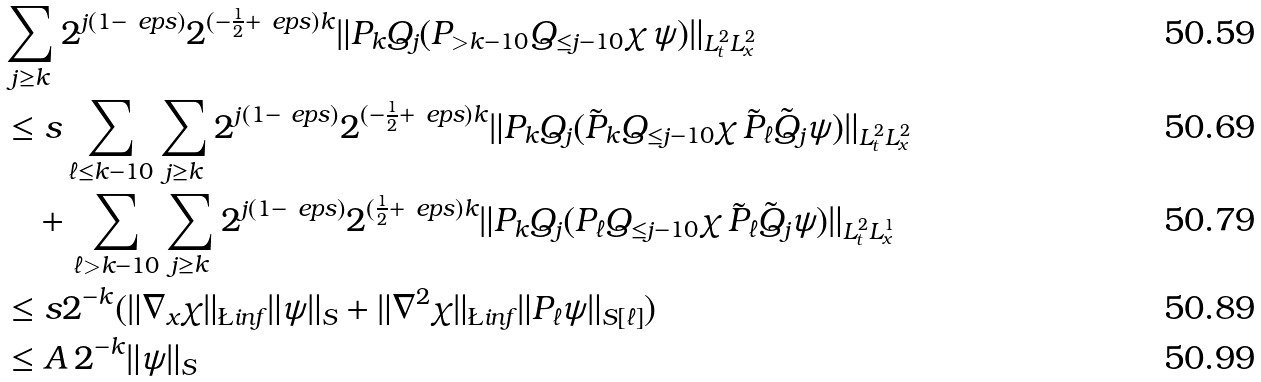<formula> <loc_0><loc_0><loc_500><loc_500>& \sum _ { j \geq k } 2 ^ { j ( 1 - \ e p s ) } 2 ^ { ( - \frac { 1 } { 2 } + \ e p s ) k } \| P _ { k } Q _ { j } ( P _ { > k - 1 0 } Q _ { \leq j - 1 0 } \chi \, \psi ) \| _ { L ^ { 2 } _ { t } L ^ { 2 } _ { x } } \\ & \leq s \sum _ { \ell \leq k - 1 0 } \sum _ { j \geq k } 2 ^ { j ( 1 - \ e p s ) } 2 ^ { ( - \frac { 1 } { 2 } + \ e p s ) k } \| P _ { k } Q _ { j } ( \tilde { P } _ { k } Q _ { \leq j - 1 0 } \chi \, \tilde { P } _ { \ell } \tilde { Q } _ { j } \psi ) \| _ { L ^ { 2 } _ { t } L ^ { 2 } _ { x } } \\ & \quad + \sum _ { \ell > k - 1 0 } \sum _ { j \geq k } 2 ^ { j ( 1 - \ e p s ) } 2 ^ { ( \frac { 1 } { 2 } + \ e p s ) k } \| P _ { k } Q _ { j } ( P _ { \ell } Q _ { \leq j - 1 0 } \chi \, \tilde { P } _ { \ell } \tilde { Q } _ { j } \psi ) \| _ { L ^ { 2 } _ { t } L ^ { 1 } _ { x } } \\ & \leq s 2 ^ { - k } ( \| \nabla _ { x } \chi \| _ { \L i n f } \| \psi \| _ { S } + \| \nabla ^ { 2 } \chi \| _ { \L i n f } \| P _ { \ell } \psi \| _ { S [ \ell ] } ) \\ & \leq A \, 2 ^ { - k } \| \psi \| _ { S }</formula> 